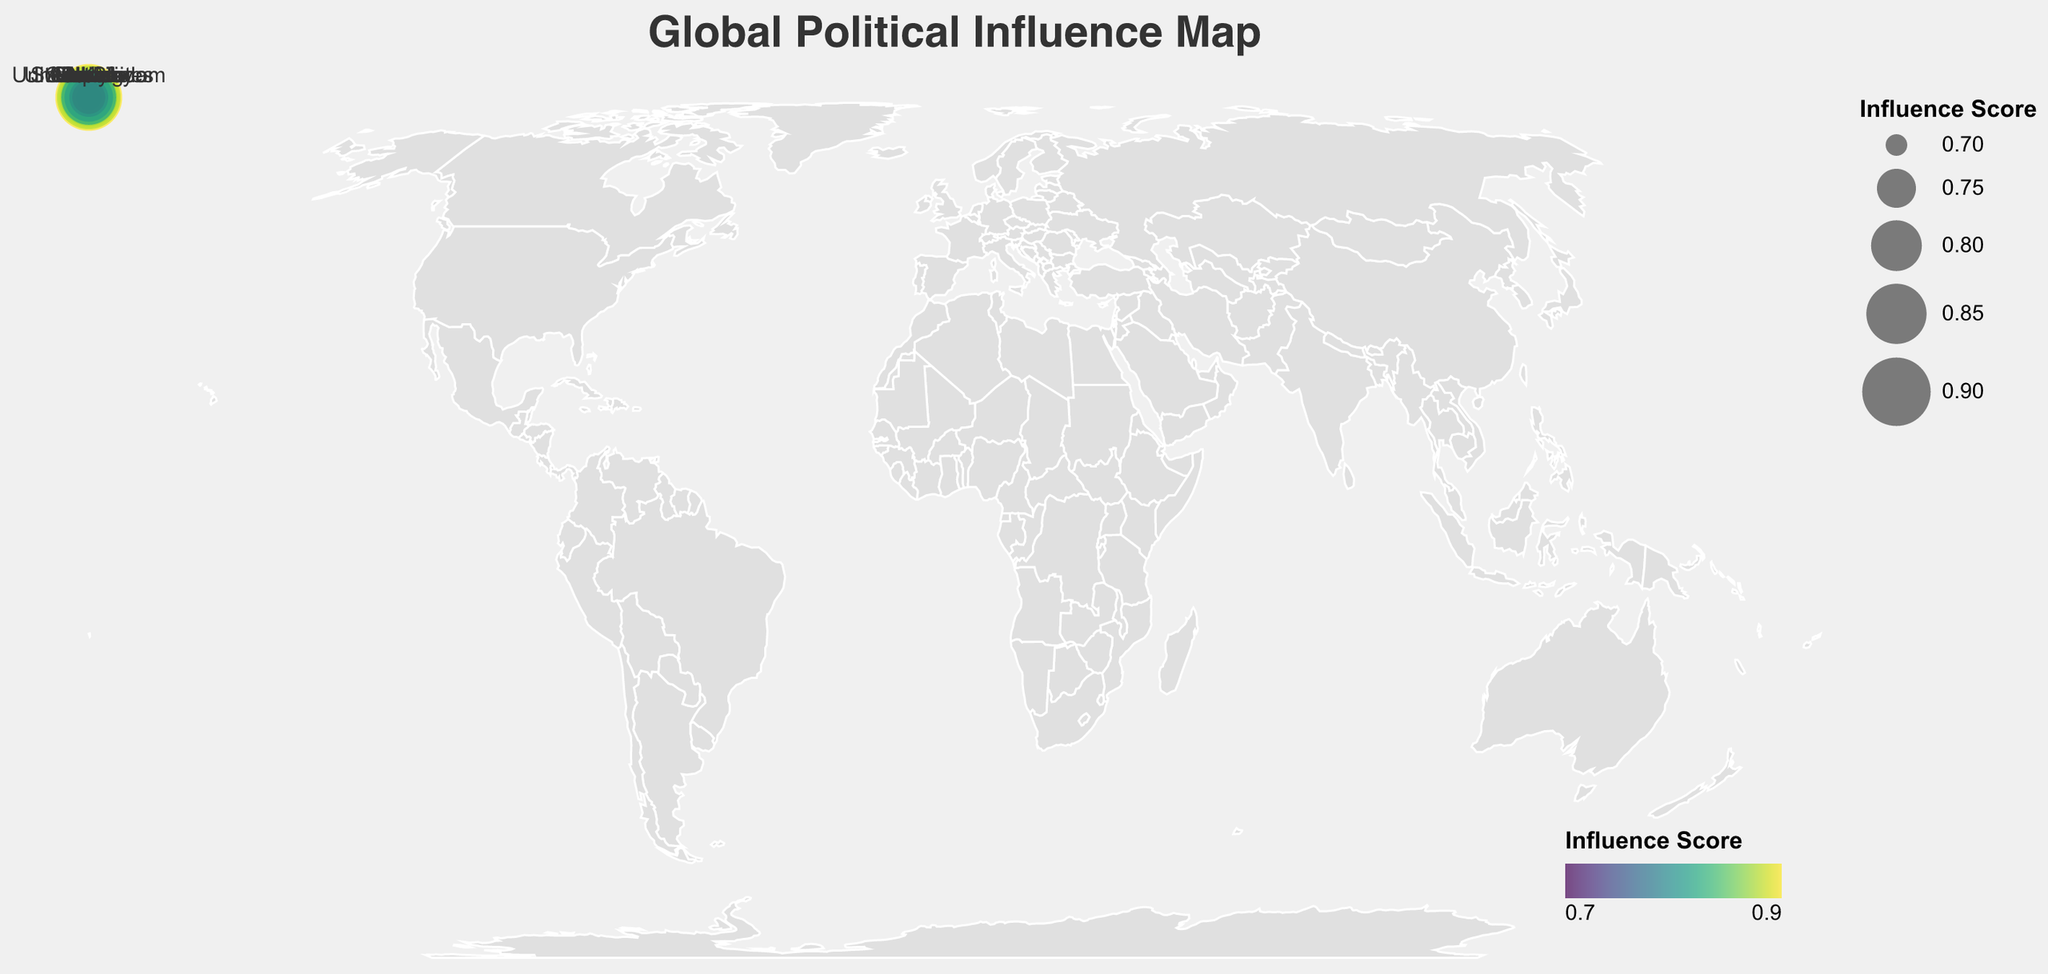What is the title of the figure? The title can be found at the top of the figure. It usually describes the content or purpose of the visualization.
Answer: Global Political Influence Map Which country has the highest influence score? By comparing all the influence scores in the figure, the highest value among them is 0.89.
Answer: India What is the sphere of influence for Sergey Lavrov? Sergey Lavrov is listed as the political ally for Russia, and his sphere of influence is specified in the data.
Answer: Foreign Affairs How many countries are represented in the figure? By counting the number of unique countries listed in the data, we can determine the total number represented in the figure.
Answer: 14 Which political ally has the closest influence score to 0.80? By looking at the influence scores, we find the one closest to 0.80. Emmanuel Macron (0.81) and Andrés Manuel López Obrador (0.82) are the closest.
Answer: Emmanuel Macron, Andrés Manuel López Obrador What is the average influence score of all the political allies? Calculate the sum of all the influence scores and divide by the number of allies. The sum (0.85 + 0.78 + 0.72 + 0.81 + 0.76 + 0.89 + 0.74 + 0.83 + 0.87 + 0.71 + 0.79 + 0.75 + 0.73 + 0.82) equals 11.25. There are 14 allies, so the average is 11.25/14.
Answer: 0.80 Among the countries, which two have allies with the most significant difference in influence scores? Calculate the difference in influence scores for each pair of countries and identify the pair with the greatest difference. The largest difference is between India (0.89) and Australia (0.71), with a difference of 0.18.
Answer: India and Australia Which country’s political ally has an influence score greater than 0.80 but less than 0.85? Identify allies with influence scores greater than 0.80 and less than 0.85. The scores that lie in this range are 0.81 (France, Macron) and 0.83 (Russia, Lavrov).
Answer: France and Russia What is the influence score range represented in the figure? Determine the smallest and largest influence scores from the data. The smallest influence score is 0.71 (Australia), and the largest is 0.89 (India).
Answer: 0.71 to 0.89 Which continent has the highest combined influence score based on the allies represented? Sum the influence scores of all allies for each continent. For instance, Europe (United Kingdom, Germany, France, Russia, Italy): 0.78+0.72+0.81+0.83+0.73 = 3.87, Asia (China, Japan, India): 0.87+0.76+0.89 = 2.52, Americas (United States, Brazil, Canada, Mexico): 0.85+0.74+0.79+0.82 = 3.20. Europe has the highest combined score.
Answer: Europe 